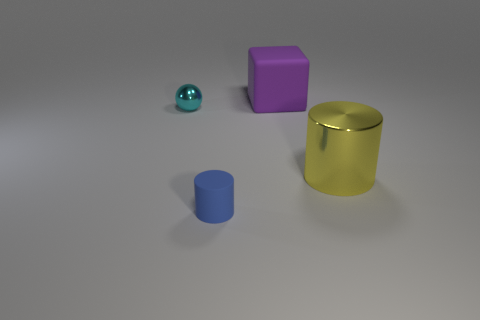Add 3 small blue objects. How many objects exist? 7 Subtract all spheres. How many objects are left? 3 Subtract all blue cylinders. How many cylinders are left? 1 Add 1 large cylinders. How many large cylinders are left? 2 Add 2 large green rubber cylinders. How many large green rubber cylinders exist? 2 Subtract 1 blue cylinders. How many objects are left? 3 Subtract 1 cylinders. How many cylinders are left? 1 Subtract all brown balls. Subtract all brown cylinders. How many balls are left? 1 Subtract all yellow spheres. How many purple cylinders are left? 0 Subtract all big yellow metallic cylinders. Subtract all green spheres. How many objects are left? 3 